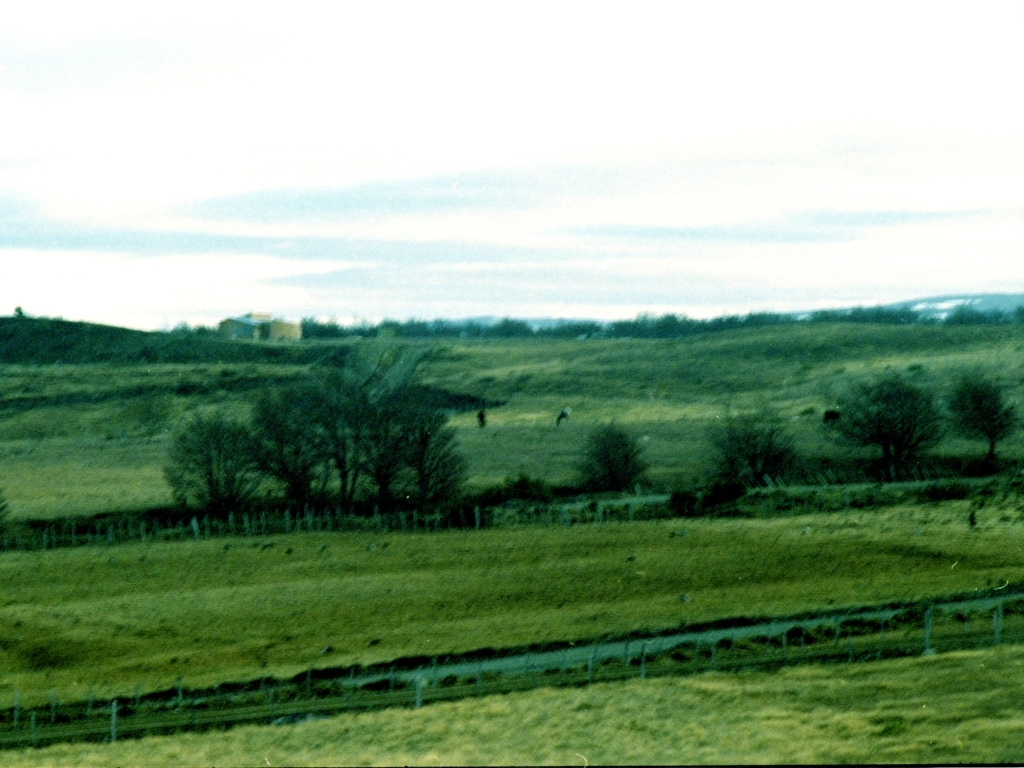What could be improved in this photograph from a compositional perspective? Compositionally, the photograph could benefit from a clear focal point to draw the viewer's eye. Including elements that offer contrast, such as a tree in the foreground or an animal in focus, would add interest. Adjusting the horizon line to adhere to the rule of thirds could also give the image a more balanced feel. 